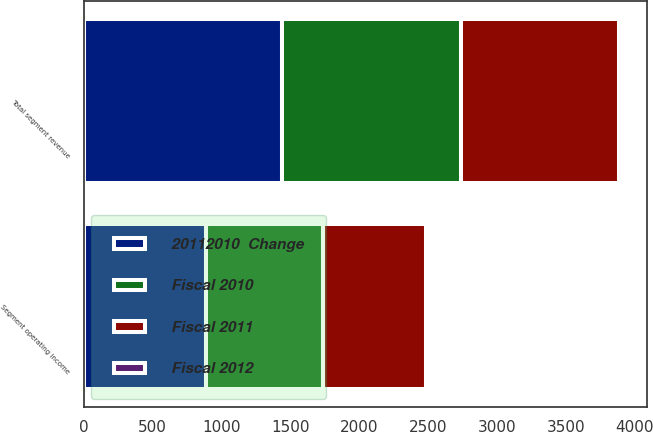<chart> <loc_0><loc_0><loc_500><loc_500><stacked_bar_chart><ecel><fcel>Total segment revenue<fcel>Segment operating income<nl><fcel>20112010  Change<fcel>1441<fcel>886<nl><fcel>Fiscal 2010<fcel>1298<fcel>850<nl><fcel>Fiscal 2011<fcel>1146<fcel>746<nl><fcel>Fiscal 2012<fcel>11<fcel>4<nl></chart> 